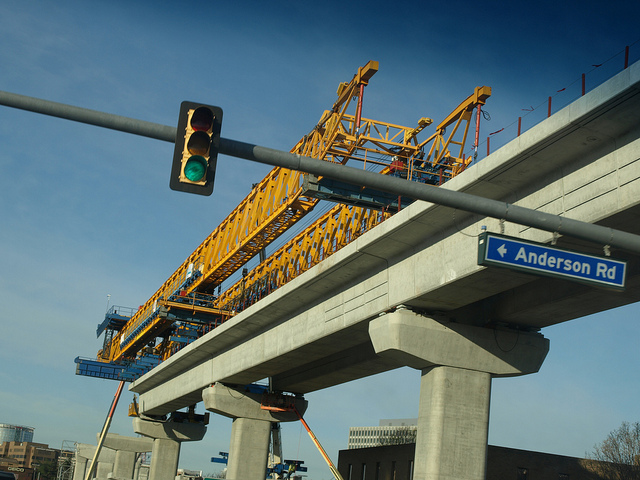Please extract the text content from this image. Anderson Rd 